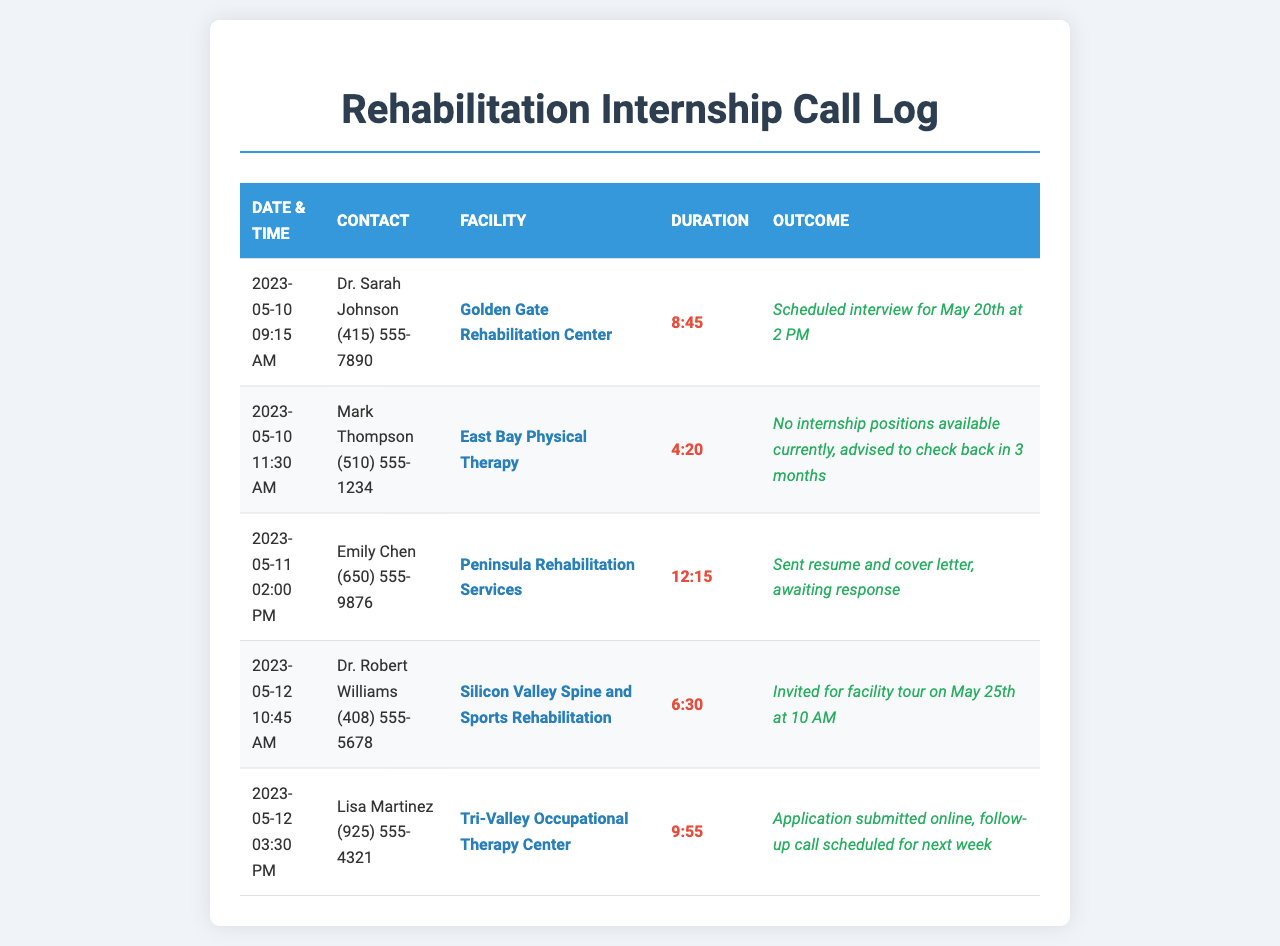What date and time was the call to Dr. Sarah Johnson? The date and time of the call to Dr. Sarah Johnson is specifically listed in the document.
Answer: 2023-05-10 09:15 AM How long was the call with Mark Thompson? The duration of the call with Mark Thompson is detailed in the document.
Answer: 4:20 What was the outcome of the call to Peninsula Rehabilitation Services? The outcome indicates the next steps after contacting Peninsula Rehabilitation Services.
Answer: Sent resume and cover letter, awaiting response Which facility invited the person for a tour? The document mentions which facility issued an invitation for a tour.
Answer: Silicon Valley Spine and Sports Rehabilitation How many calls were made on May 12th? By counting the entries on May 12th, we can determine the number of calls made.
Answer: 2 